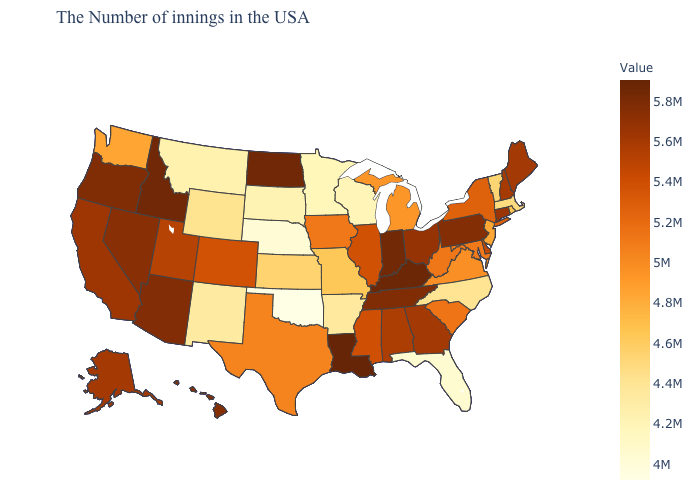Which states hav the highest value in the Northeast?
Write a very short answer. Pennsylvania. Among the states that border Oklahoma , which have the highest value?
Concise answer only. Colorado. Does Louisiana have the highest value in the USA?
Quick response, please. Yes. Does Mississippi have the highest value in the USA?
Keep it brief. No. Does Washington have a higher value than Wisconsin?
Answer briefly. Yes. 